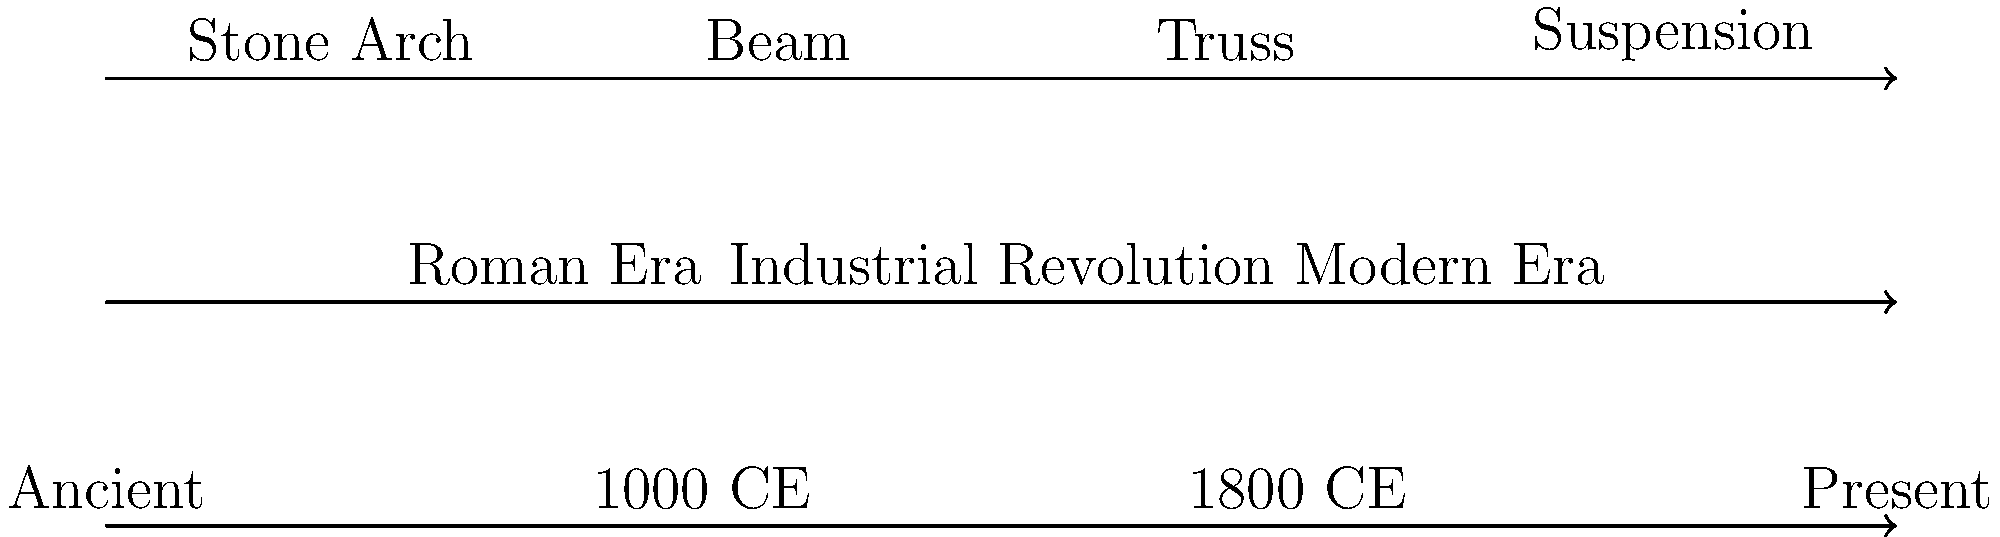Based on the timeline of bridge design evolution shown in the graphic, which type of bridge design emerged during the Industrial Revolution and became prevalent in the Modern Era, challenging the traditional reliance on ancient architectural forms? To answer this question, we need to analyze the information presented in the timeline graphic:

1. The graphic shows four main bridge designs: Stone Arch, Beam, Truss, and Suspension.
2. The timeline is divided into three main eras: Roman Era, Industrial Revolution, and Modern Era.
3. The chronological progression moves from left to right, with "Ancient" at the far left and "Present" at the far right.

4. Stone Arch bridges are positioned earliest on the timeline, corresponding to the Roman Era and earlier.
5. Beam bridges appear to span from the Roman Era into the Industrial Revolution.
6. Truss bridges are shown emerging during the Industrial Revolution and continuing into the Modern Era.
7. Suspension bridges are positioned latest on the timeline, primarily in the Modern Era.

Given the question's focus on a design that emerged during the Industrial Revolution and became prevalent in the Modern Era, we can deduce that the Truss bridge design fits this description. It challenges traditional reliance on ancient architectural forms (like Stone Arch) by introducing a new structural approach that became widely used in modern times.

This analysis aligns with historical facts: truss bridges indeed became popular during the Industrial Revolution due to the availability of iron and steel, and their ability to span longer distances efficiently. They continued to be widely used in the Modern Era, representing a significant shift from ancient bridge-building techniques.
Answer: Truss bridges 